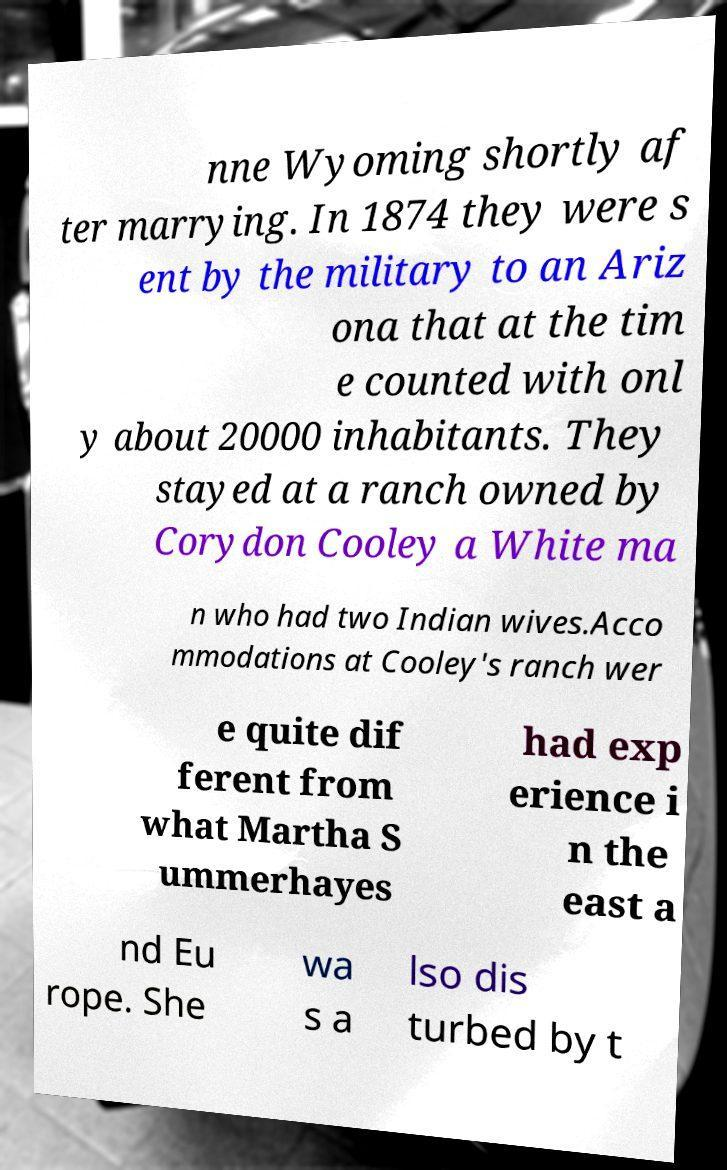What messages or text are displayed in this image? I need them in a readable, typed format. nne Wyoming shortly af ter marrying. In 1874 they were s ent by the military to an Ariz ona that at the tim e counted with onl y about 20000 inhabitants. They stayed at a ranch owned by Corydon Cooley a White ma n who had two Indian wives.Acco mmodations at Cooley's ranch wer e quite dif ferent from what Martha S ummerhayes had exp erience i n the east a nd Eu rope. She wa s a lso dis turbed by t 